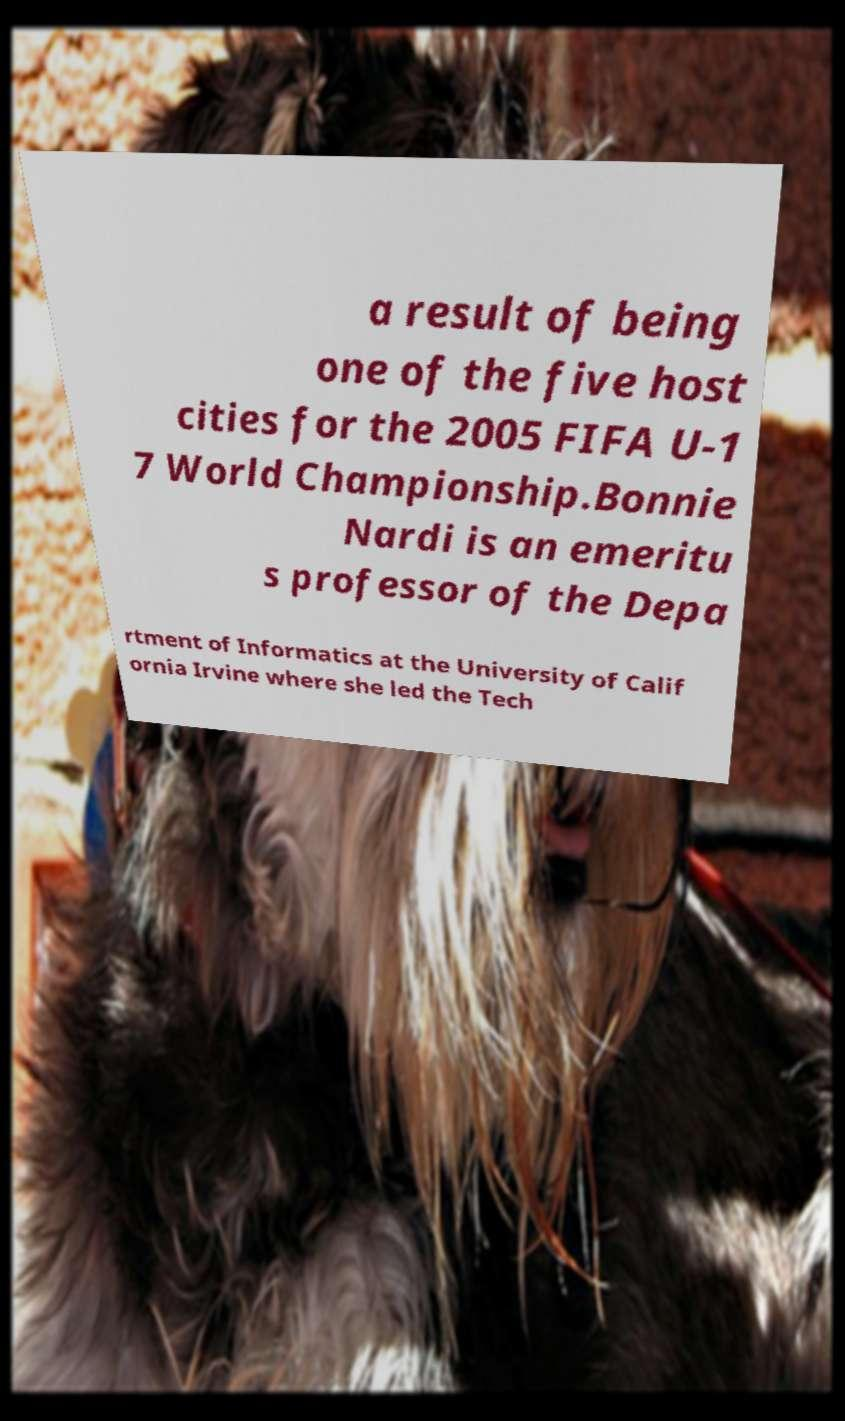Could you extract and type out the text from this image? a result of being one of the five host cities for the 2005 FIFA U-1 7 World Championship.Bonnie Nardi is an emeritu s professor of the Depa rtment of Informatics at the University of Calif ornia Irvine where she led the Tech 